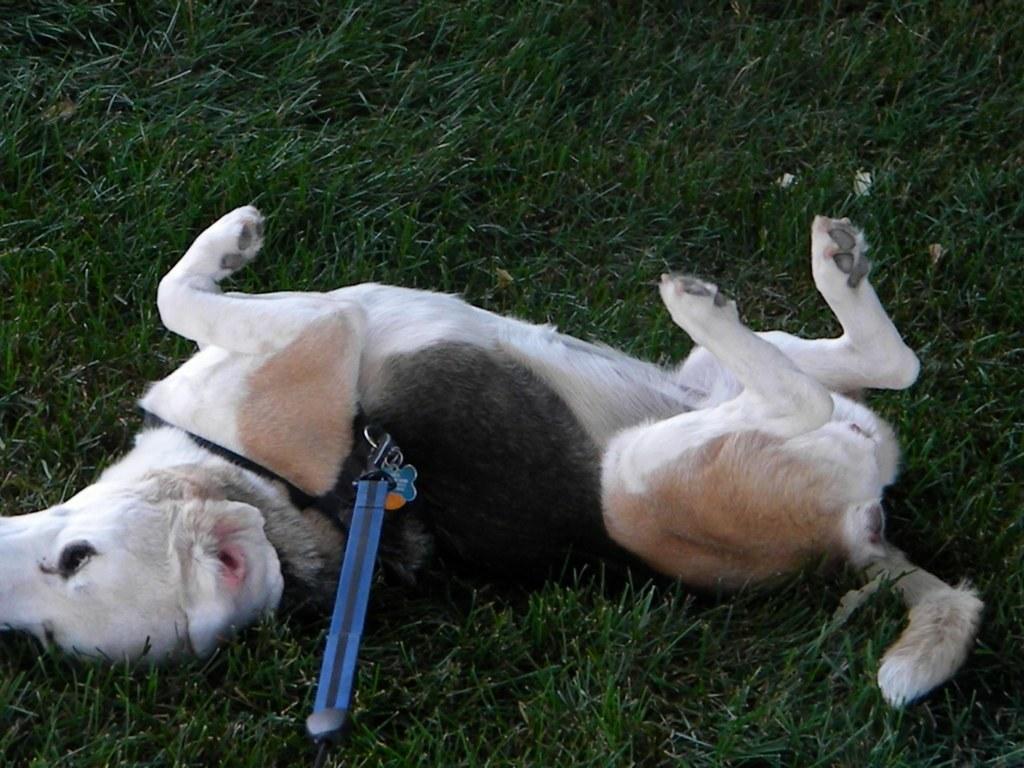Describe this image in one or two sentences. In this image we can see grass on the ground. On that there is a dog lying. And the dog is having a collar with blue color thing on that.. 